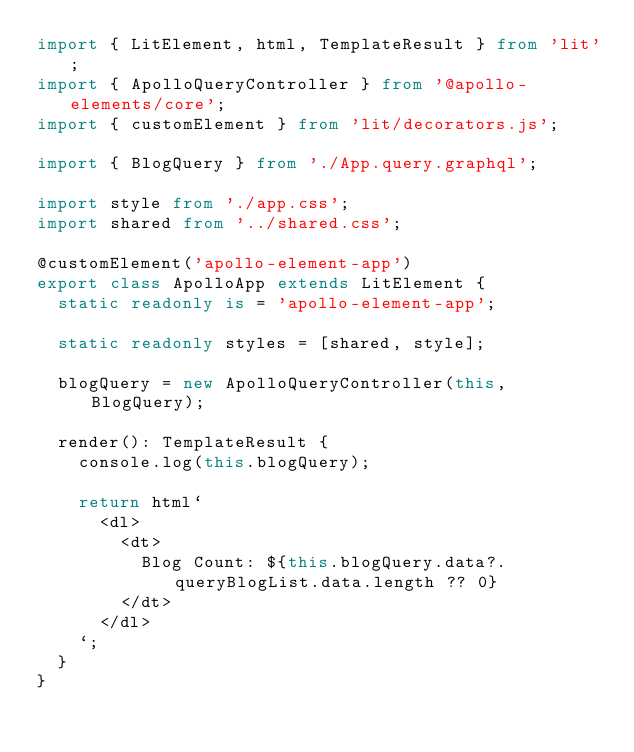Convert code to text. <code><loc_0><loc_0><loc_500><loc_500><_TypeScript_>import { LitElement, html, TemplateResult } from 'lit';
import { ApolloQueryController } from '@apollo-elements/core';
import { customElement } from 'lit/decorators.js';

import { BlogQuery } from './App.query.graphql';

import style from './app.css';
import shared from '../shared.css';

@customElement('apollo-element-app')
export class ApolloApp extends LitElement {
  static readonly is = 'apollo-element-app';

  static readonly styles = [shared, style];

  blogQuery = new ApolloQueryController(this, BlogQuery);

  render(): TemplateResult {
    console.log(this.blogQuery);

    return html`
      <dl>
        <dt>
          Blog Count: ${this.blogQuery.data?.queryBlogList.data.length ?? 0}
        </dt>
      </dl>
    `;
  }
}
</code> 